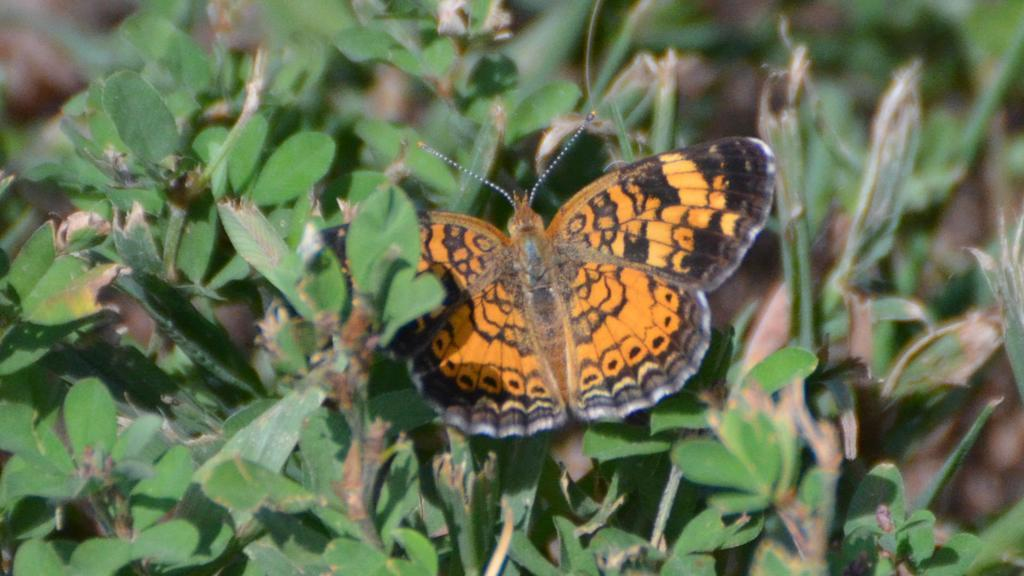What is the main subject of the image? There is a butterfly in the image. Where is the butterfly located? The butterfly is on plants. What time of day is the image likely taken? The image is likely taken during the day. What type of environment is the image likely taken in? The image is likely taken in a garden. What is the purpose of the flower in the image? There is no flower present in the image; it features a butterfly on plants. What type of butter is depicted in the image? There is no butter present in the image; it features a butterfly on plants. 